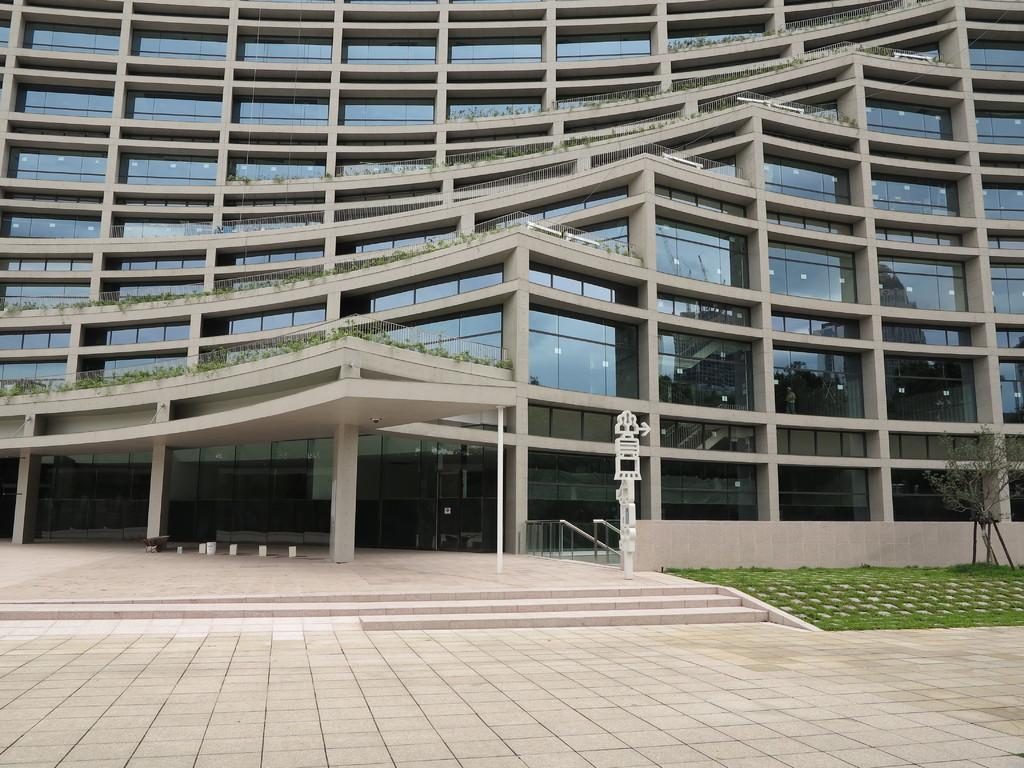What is the main structure in the image? There is a building in the image. What is on the building? There are plants on the building. What type of vegetation can be seen on the right side of the image? There is grass visible on the right side of the image. How many balls can be seen rolling on the grass in the image? There are no balls visible in the image; it only features a building with plants and grass on the right side. 